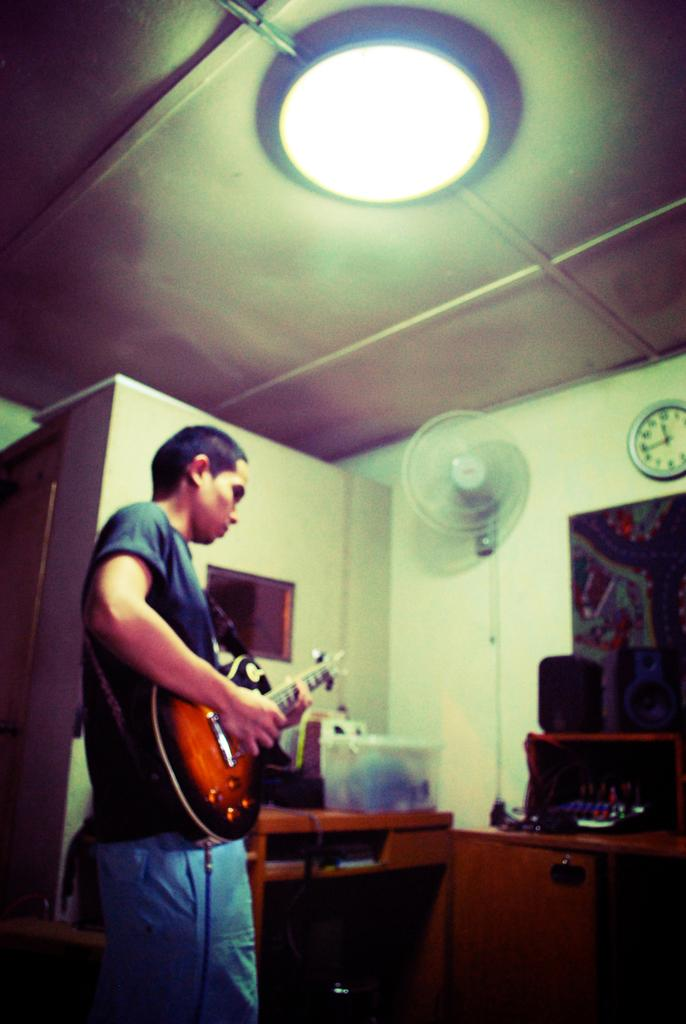What is the man in the image doing? The man is playing a guitar in the image. What object can be seen providing light in the image? There is a light in the image. What type of furniture is present in the image? There is a table in the image. What is attached to the wall in the image? There is a fan on the wall in the image. What time-related object is visible in the image? There is a clock in the image. What type of coal is being used to fuel the donkey in the image? There is no donkey or coal present in the image. What type of crime is being committed in the image? There is no crime being committed in the image; it features a man playing a guitar and other objects. 